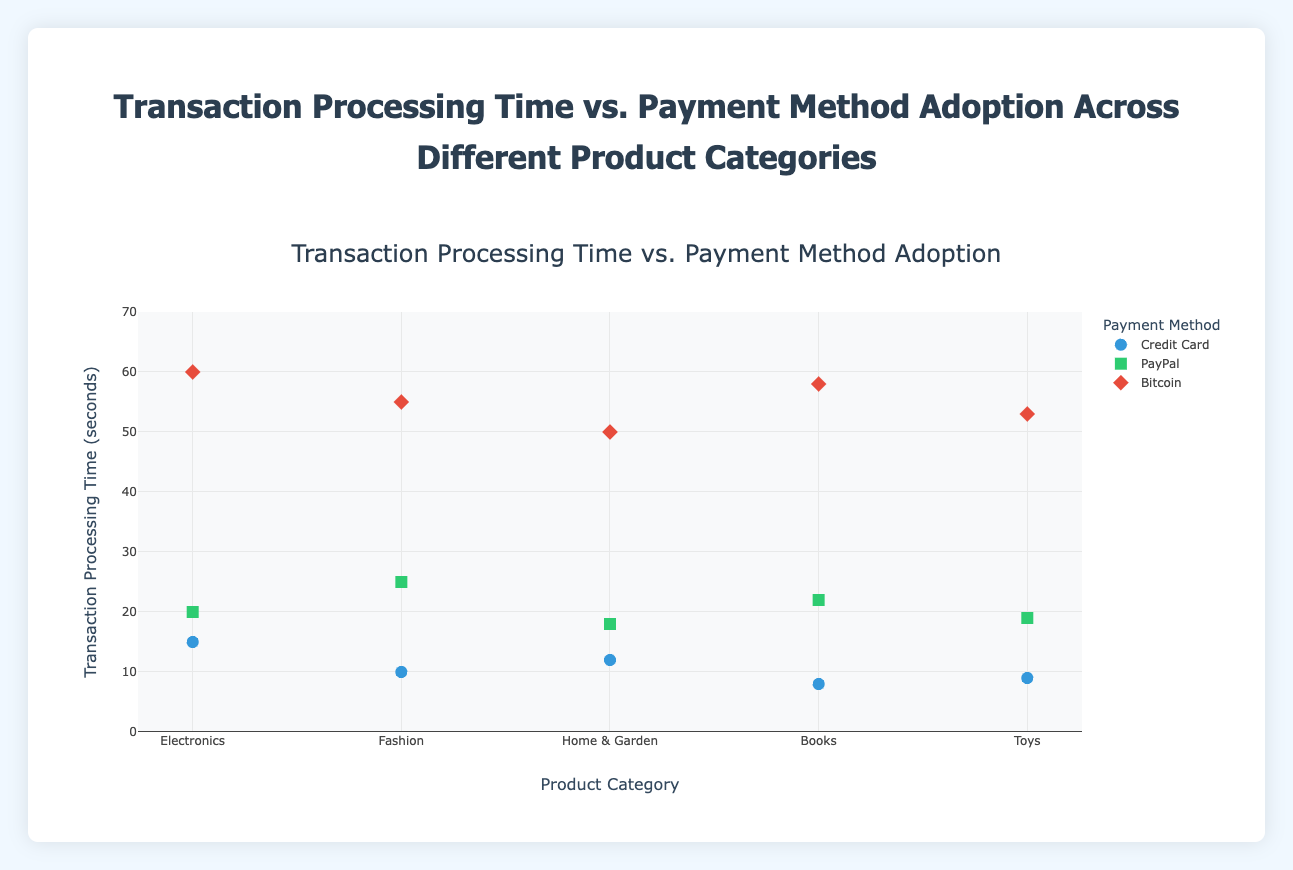What's the title of the figure? The title of the figure is written at the top and usually describes the content succinctly.
Answer: Transaction Processing Time vs. Payment Method Adoption Across Different Product Categories What is the y-axis label? The label on the y-axis indicates what the axis represents in the context of the plot. Here, it shows the time taken to process transactions.
Answer: Transaction Processing Time (seconds) Which product category has the fastest transaction processing time with a credit card? To find the fastest time, look at the data points for each product category using a credit card and identify the lowest value on the y-axis.
Answer: Books How does the transaction processing time for Bitcoin compare to Credit Card in the Electronics category? Find the data points in the Electronics category, compare the y-values for Bitcoin and Credit Card transactions.
Answer: Bitcoin is slower What is the difference in transaction processing time between PayPal and Bitcoin for the Fashion category? Identify the y-values for PayPal and Bitcoin in the Fashion category, then subtract the lower value from the higher.
Answer: 30 seconds On average, which category has the slowest transaction processing time? Calculate the average transaction processing time for each product category by summing the respective y-values and dividing by the number of points. Identify the category with the highest average value.
Answer: Electronics What’s the median processing time for Bitcoin across all categories? List out the transaction processing times for Bitcoin, sort them in ascending order, and find the middle value. If the list has an even number of entries, average the two middle numbers.
Answer: 56.5 seconds Which payment method is generally the fastest across all categories? Compare the overall distribution of y-values for each payment method by visually assessing their positions on the y-axis.
Answer: Credit Card Are there any categories where Bitcoin is faster than PayPal? Compare the data points within each category to see if the Bitcoin transaction time is lower than that of PayPal.
Answer: No How does the transaction processing time for PayPal vary across different product categories? Check the distribution of PayPal data points along the y-axis across all categories, noting the range and any significant differences.
Answer: Ranges from 18 to 25 seconds 